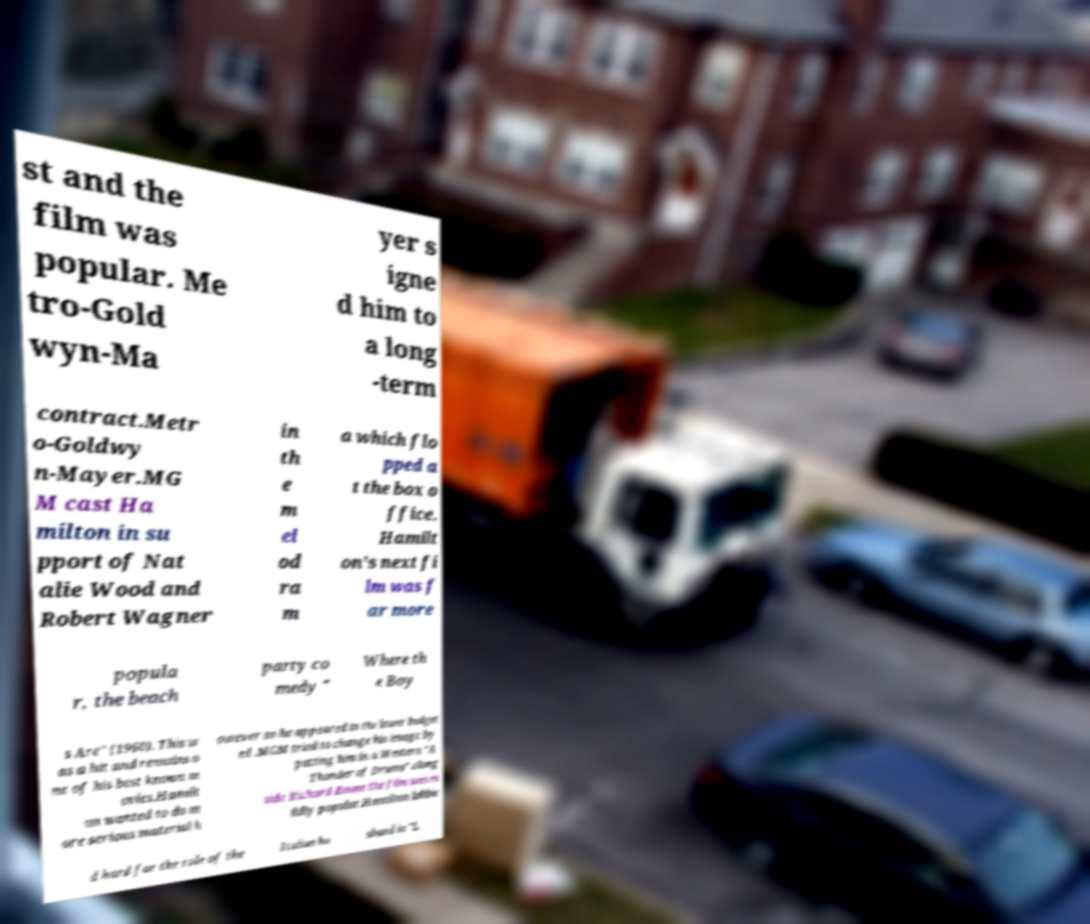Can you accurately transcribe the text from the provided image for me? st and the film was popular. Me tro-Gold wyn-Ma yer s igne d him to a long -term contract.Metr o-Goldwy n-Mayer.MG M cast Ha milton in su pport of Nat alie Wood and Robert Wagner in th e m el od ra m a which flo pped a t the box o ffice. Hamilt on's next fi lm was f ar more popula r, the beach party co medy " Where th e Boy s Are" (1960). This w as a hit and remains o ne of his best known m ovies.Hamilt on wanted to do m ore serious material h owever so he appeared in the lower budget ed .MGM tried to change his image by putting him in a Western "A Thunder of Drums" along side Richard Boone the film was m ildly popular.Hamilton lobbie d hard for the role of the Italian hu sband in "L 